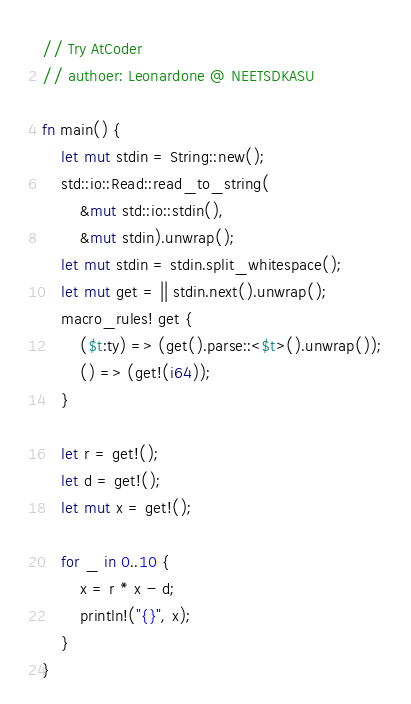Convert code to text. <code><loc_0><loc_0><loc_500><loc_500><_Rust_>// Try AtCoder
// authoer: Leonardone @ NEETSDKASU

fn main() {
    let mut stdin = String::new();
    std::io::Read::read_to_string(
        &mut std::io::stdin(),
        &mut stdin).unwrap();
    let mut stdin = stdin.split_whitespace();
    let mut get = || stdin.next().unwrap();
    macro_rules! get {
        ($t:ty) => (get().parse::<$t>().unwrap());
        () => (get!(i64));
    }
    
    let r = get!();
    let d = get!();
    let mut x = get!();
    
    for _ in 0..10 {
        x = r * x - d;
        println!("{}", x);
    }
}</code> 